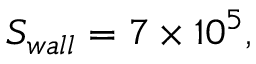<formula> <loc_0><loc_0><loc_500><loc_500>S _ { w a l l } = 7 \times 1 0 ^ { 5 } ,</formula> 